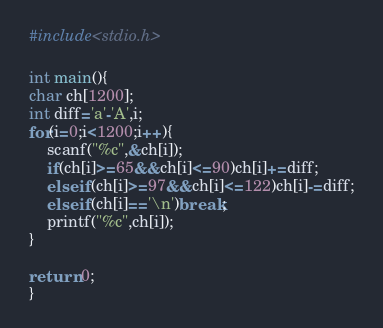<code> <loc_0><loc_0><loc_500><loc_500><_C_>#include<stdio.h>

int main(){
char ch[1200];
int diff='a'-'A',i;
for(i=0;i<1200;i++){
	scanf("%c",&ch[i]);
	if(ch[i]>=65&&ch[i]<=90)ch[i]+=diff;
	else if(ch[i]>=97&&ch[i]<=122)ch[i]-=diff;
	else if(ch[i]=='\n')break;
	printf("%c",ch[i]);
}

return 0;
}</code> 